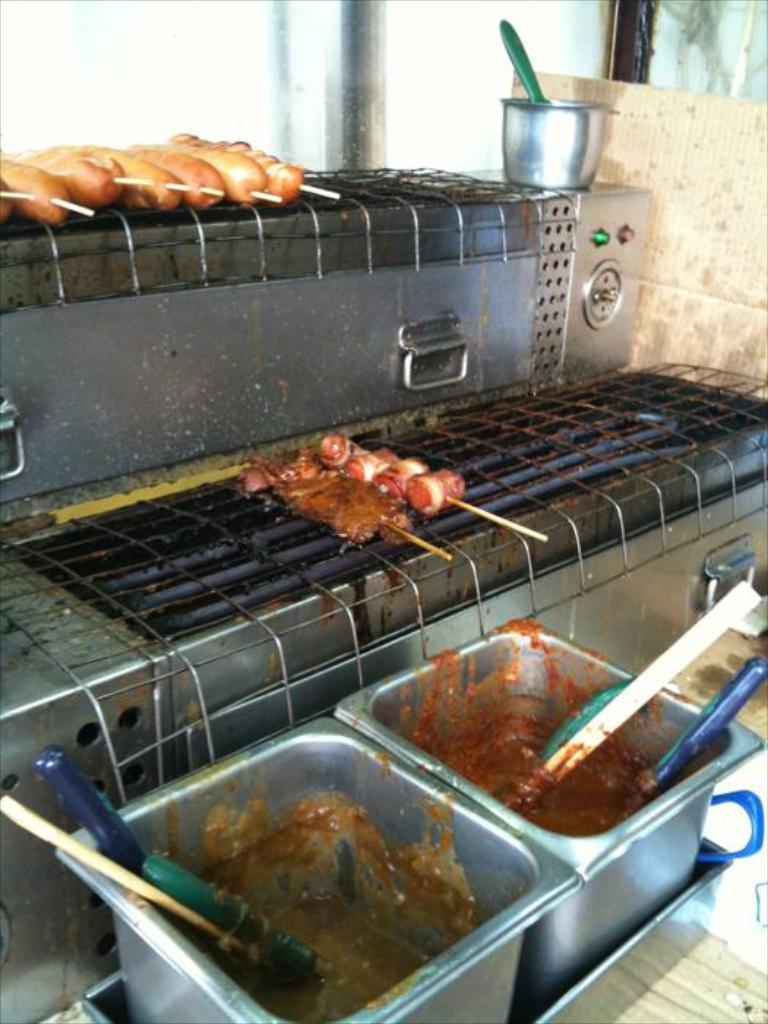What is being cooked on the grills in the image? There is food placed on the grills in the image. What additional items are present near the grills? There are two bowls in front of the grills. Can you describe any other objects visible in the image? There is a glass in the background of the image. What type of pan is being used to cook the food in the image? There is no pan visible in the image; the food is being cooked on grills. Can you describe the temperature of the food being cooked in the image? The provided facts do not mention the temperature of the food being cooked, so it cannot be determined from the image. 